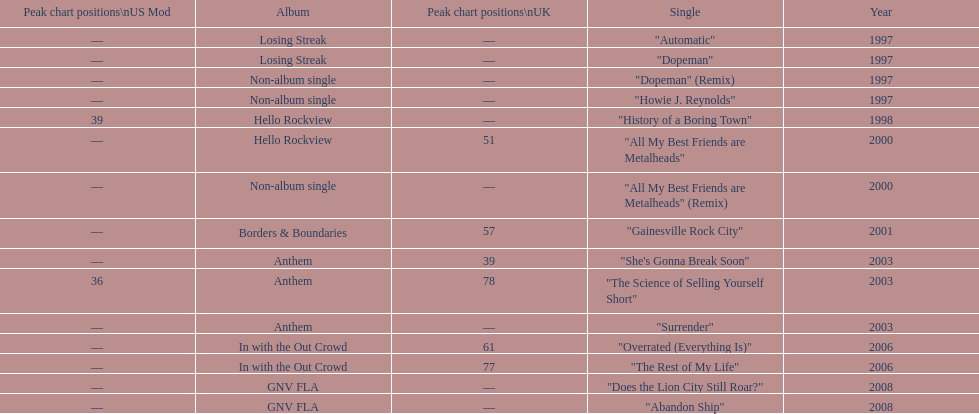Which album had the single automatic? Losing Streak. 